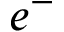Convert formula to latex. <formula><loc_0><loc_0><loc_500><loc_500>e ^ { - }</formula> 